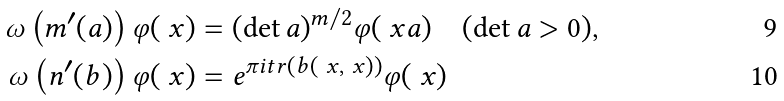<formula> <loc_0><loc_0><loc_500><loc_500>\omega \left ( m ^ { \prime } ( a ) \right ) \varphi ( \ x ) & = ( \det a ) ^ { m / 2 } \varphi ( \ x a ) \quad ( \det a > 0 ) , \\ \omega \left ( n ^ { \prime } ( b ) \right ) \varphi ( \ x ) & = e ^ { \pi i t r ( b ( \ x , \ x ) ) } \varphi ( \ x )</formula> 